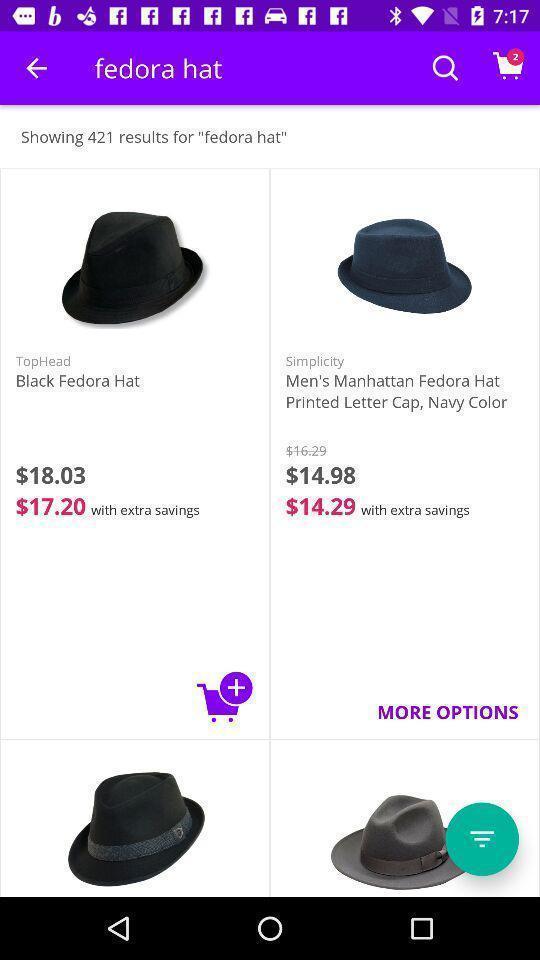Tell me what you see in this picture. Screen displaying list of hats on a shopping app. 